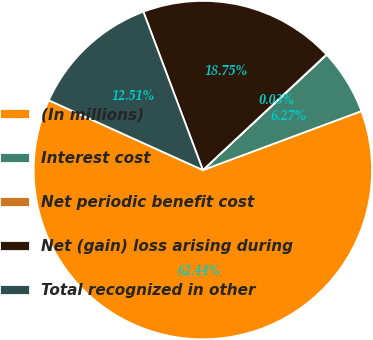Convert chart to OTSL. <chart><loc_0><loc_0><loc_500><loc_500><pie_chart><fcel>(In millions)<fcel>Interest cost<fcel>Net periodic benefit cost<fcel>Net (gain) loss arising during<fcel>Total recognized in other<nl><fcel>62.43%<fcel>6.27%<fcel>0.03%<fcel>18.75%<fcel>12.51%<nl></chart> 